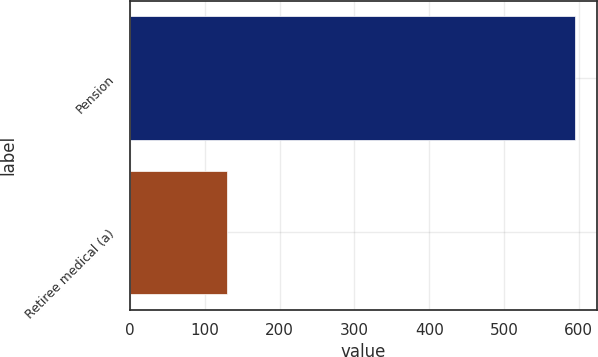<chart> <loc_0><loc_0><loc_500><loc_500><bar_chart><fcel>Pension<fcel>Retiree medical (a)<nl><fcel>595<fcel>130<nl></chart> 